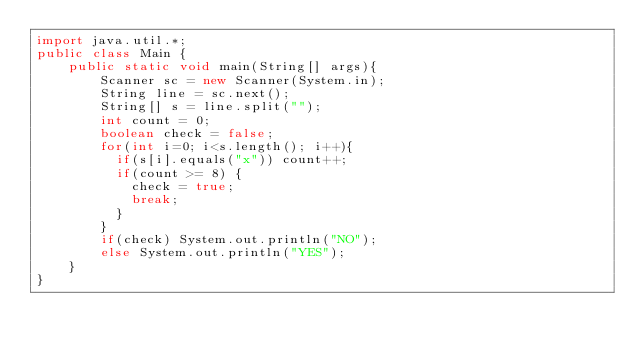Convert code to text. <code><loc_0><loc_0><loc_500><loc_500><_Java_>import java.util.*;
public class Main {
	public static void main(String[] args){
		Scanner sc = new Scanner(System.in);
        String line = sc.next();
        String[] s = line.split("");
        int count = 0;
        boolean check = false;
        for(int i=0; i<s.length(); i++){
          if(s[i].equals("x")) count++;
          if(count >= 8) {
            check = true;
            break;
          }
        }
        if(check) System.out.println("NO");
        else System.out.println("YES");
	}
}</code> 